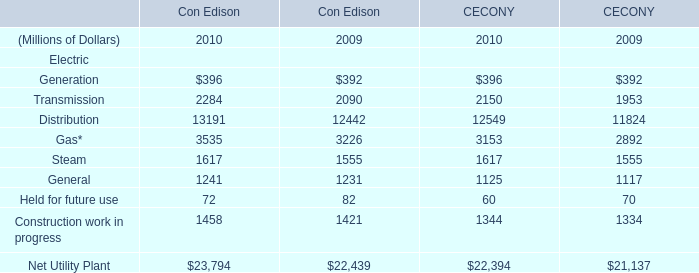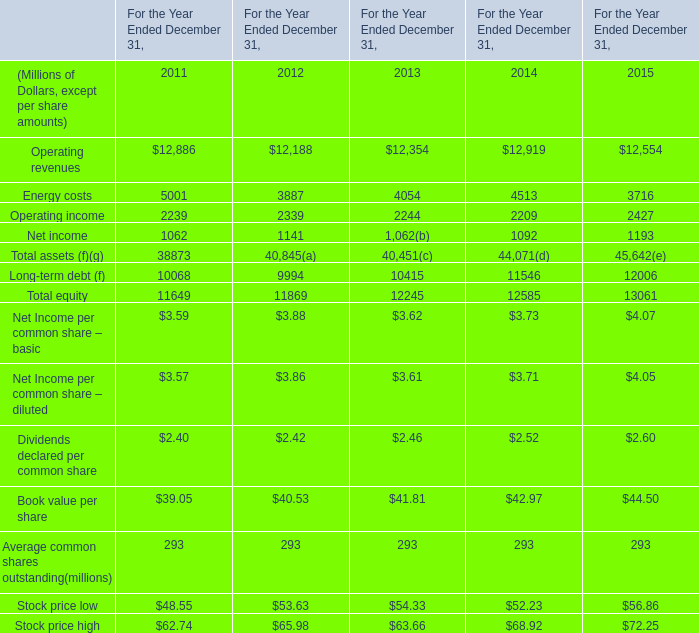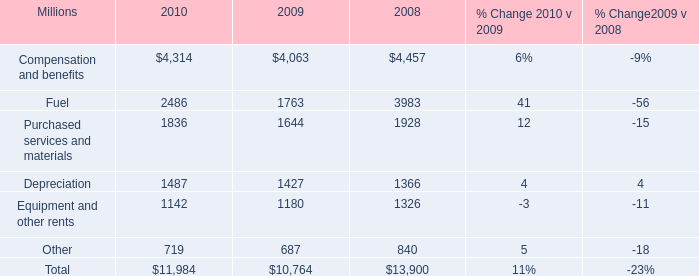What is the sum of Net income of For the Year Ended December 31, 2012, Compensation and benefits of 2009, and Fuel of 2008 ? 
Computations: ((1141.0 + 4063.0) + 3983.0)
Answer: 9187.0. 